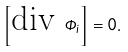Convert formula to latex. <formula><loc_0><loc_0><loc_500><loc_500>\left [ \text {div } \Phi _ { i } \right ] = 0 .</formula> 